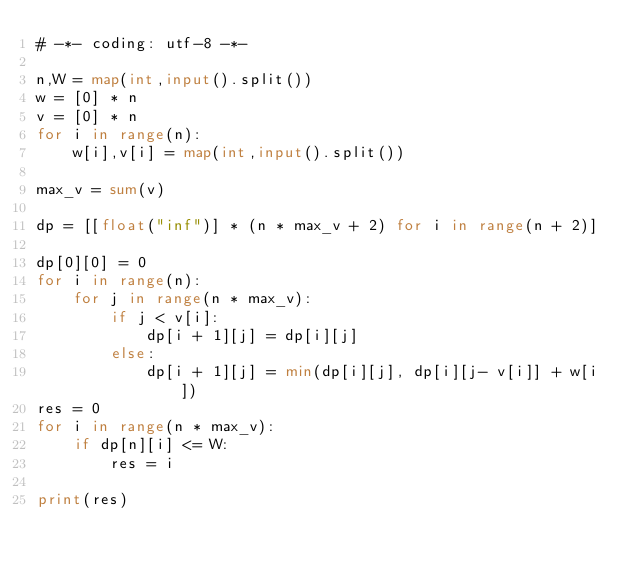<code> <loc_0><loc_0><loc_500><loc_500><_Python_># -*- coding: utf-8 -*-

n,W = map(int,input().split())
w = [0] * n
v = [0] * n
for i in range(n):
    w[i],v[i] = map(int,input().split())

max_v = sum(v)

dp = [[float("inf")] * (n * max_v + 2) for i in range(n + 2)]

dp[0][0] = 0
for i in range(n):
    for j in range(n * max_v):
        if j < v[i]:
            dp[i + 1][j] = dp[i][j]
        else:
            dp[i + 1][j] = min(dp[i][j], dp[i][j- v[i]] + w[i])
res = 0
for i in range(n * max_v):
    if dp[n][i] <= W:
        res = i

print(res)
</code> 